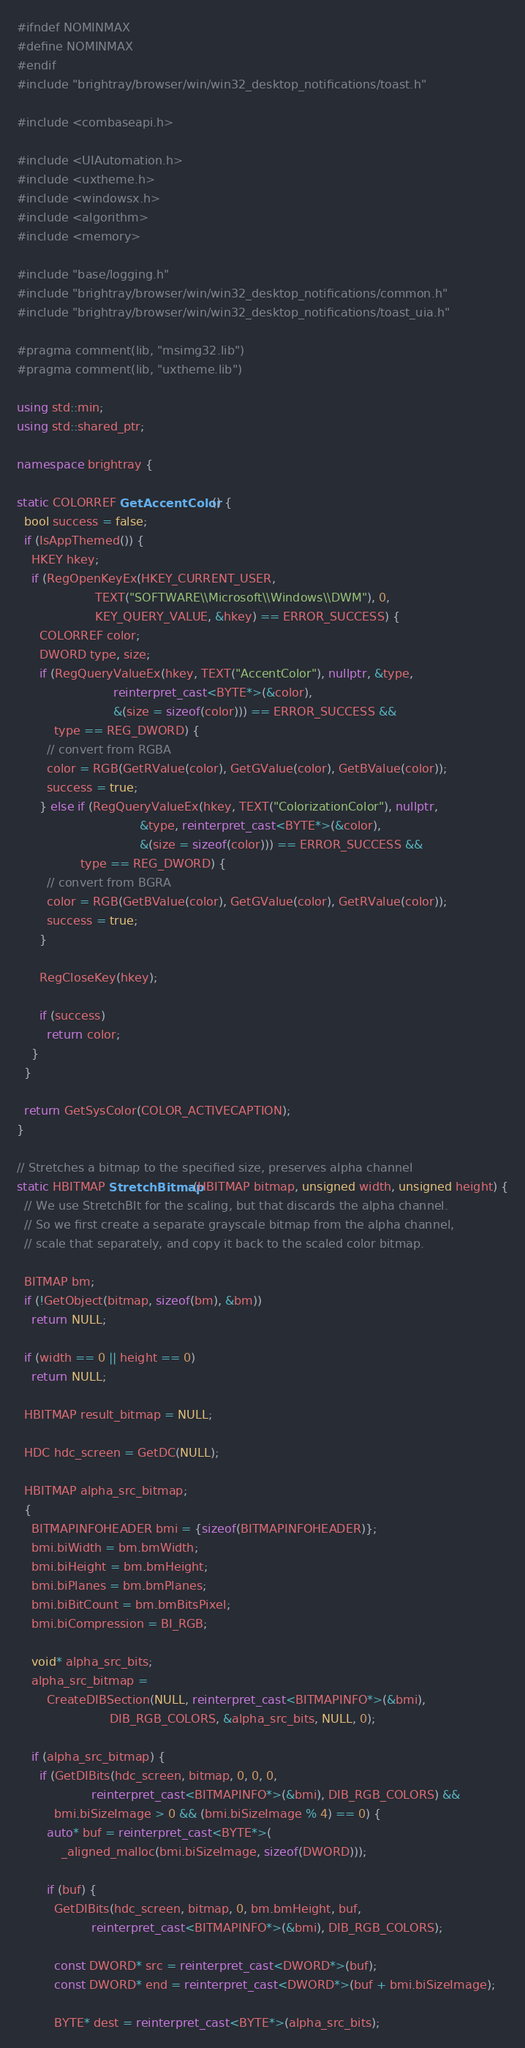Convert code to text. <code><loc_0><loc_0><loc_500><loc_500><_C++_>#ifndef NOMINMAX
#define NOMINMAX
#endif
#include "brightray/browser/win/win32_desktop_notifications/toast.h"

#include <combaseapi.h>

#include <UIAutomation.h>
#include <uxtheme.h>
#include <windowsx.h>
#include <algorithm>
#include <memory>

#include "base/logging.h"
#include "brightray/browser/win/win32_desktop_notifications/common.h"
#include "brightray/browser/win/win32_desktop_notifications/toast_uia.h"

#pragma comment(lib, "msimg32.lib")
#pragma comment(lib, "uxtheme.lib")

using std::min;
using std::shared_ptr;

namespace brightray {

static COLORREF GetAccentColor() {
  bool success = false;
  if (IsAppThemed()) {
    HKEY hkey;
    if (RegOpenKeyEx(HKEY_CURRENT_USER,
                     TEXT("SOFTWARE\\Microsoft\\Windows\\DWM"), 0,
                     KEY_QUERY_VALUE, &hkey) == ERROR_SUCCESS) {
      COLORREF color;
      DWORD type, size;
      if (RegQueryValueEx(hkey, TEXT("AccentColor"), nullptr, &type,
                          reinterpret_cast<BYTE*>(&color),
                          &(size = sizeof(color))) == ERROR_SUCCESS &&
          type == REG_DWORD) {
        // convert from RGBA
        color = RGB(GetRValue(color), GetGValue(color), GetBValue(color));
        success = true;
      } else if (RegQueryValueEx(hkey, TEXT("ColorizationColor"), nullptr,
                                 &type, reinterpret_cast<BYTE*>(&color),
                                 &(size = sizeof(color))) == ERROR_SUCCESS &&
                 type == REG_DWORD) {
        // convert from BGRA
        color = RGB(GetBValue(color), GetGValue(color), GetRValue(color));
        success = true;
      }

      RegCloseKey(hkey);

      if (success)
        return color;
    }
  }

  return GetSysColor(COLOR_ACTIVECAPTION);
}

// Stretches a bitmap to the specified size, preserves alpha channel
static HBITMAP StretchBitmap(HBITMAP bitmap, unsigned width, unsigned height) {
  // We use StretchBlt for the scaling, but that discards the alpha channel.
  // So we first create a separate grayscale bitmap from the alpha channel,
  // scale that separately, and copy it back to the scaled color bitmap.

  BITMAP bm;
  if (!GetObject(bitmap, sizeof(bm), &bm))
    return NULL;

  if (width == 0 || height == 0)
    return NULL;

  HBITMAP result_bitmap = NULL;

  HDC hdc_screen = GetDC(NULL);

  HBITMAP alpha_src_bitmap;
  {
    BITMAPINFOHEADER bmi = {sizeof(BITMAPINFOHEADER)};
    bmi.biWidth = bm.bmWidth;
    bmi.biHeight = bm.bmHeight;
    bmi.biPlanes = bm.bmPlanes;
    bmi.biBitCount = bm.bmBitsPixel;
    bmi.biCompression = BI_RGB;

    void* alpha_src_bits;
    alpha_src_bitmap =
        CreateDIBSection(NULL, reinterpret_cast<BITMAPINFO*>(&bmi),
                         DIB_RGB_COLORS, &alpha_src_bits, NULL, 0);

    if (alpha_src_bitmap) {
      if (GetDIBits(hdc_screen, bitmap, 0, 0, 0,
                    reinterpret_cast<BITMAPINFO*>(&bmi), DIB_RGB_COLORS) &&
          bmi.biSizeImage > 0 && (bmi.biSizeImage % 4) == 0) {
        auto* buf = reinterpret_cast<BYTE*>(
            _aligned_malloc(bmi.biSizeImage, sizeof(DWORD)));

        if (buf) {
          GetDIBits(hdc_screen, bitmap, 0, bm.bmHeight, buf,
                    reinterpret_cast<BITMAPINFO*>(&bmi), DIB_RGB_COLORS);

          const DWORD* src = reinterpret_cast<DWORD*>(buf);
          const DWORD* end = reinterpret_cast<DWORD*>(buf + bmi.biSizeImage);

          BYTE* dest = reinterpret_cast<BYTE*>(alpha_src_bits);
</code> 